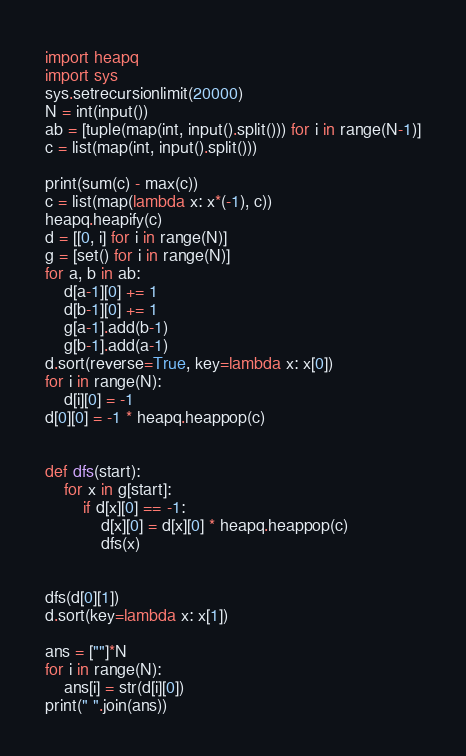<code> <loc_0><loc_0><loc_500><loc_500><_Python_>import heapq
import sys
sys.setrecursionlimit(20000)
N = int(input())
ab = [tuple(map(int, input().split())) for i in range(N-1)]
c = list(map(int, input().split()))

print(sum(c) - max(c))
c = list(map(lambda x: x*(-1), c))
heapq.heapify(c)
d = [[0, i] for i in range(N)]
g = [set() for i in range(N)]
for a, b in ab:
    d[a-1][0] += 1
    d[b-1][0] += 1
    g[a-1].add(b-1)
    g[b-1].add(a-1)
d.sort(reverse=True, key=lambda x: x[0])
for i in range(N):
    d[i][0] = -1
d[0][0] = -1 * heapq.heappop(c)


def dfs(start):
    for x in g[start]:
        if d[x][0] == -1:
            d[x][0] = d[x][0] * heapq.heappop(c)
            dfs(x)


dfs(d[0][1])
d.sort(key=lambda x: x[1])

ans = [""]*N
for i in range(N):
    ans[i] = str(d[i][0])
print(" ".join(ans))
</code> 